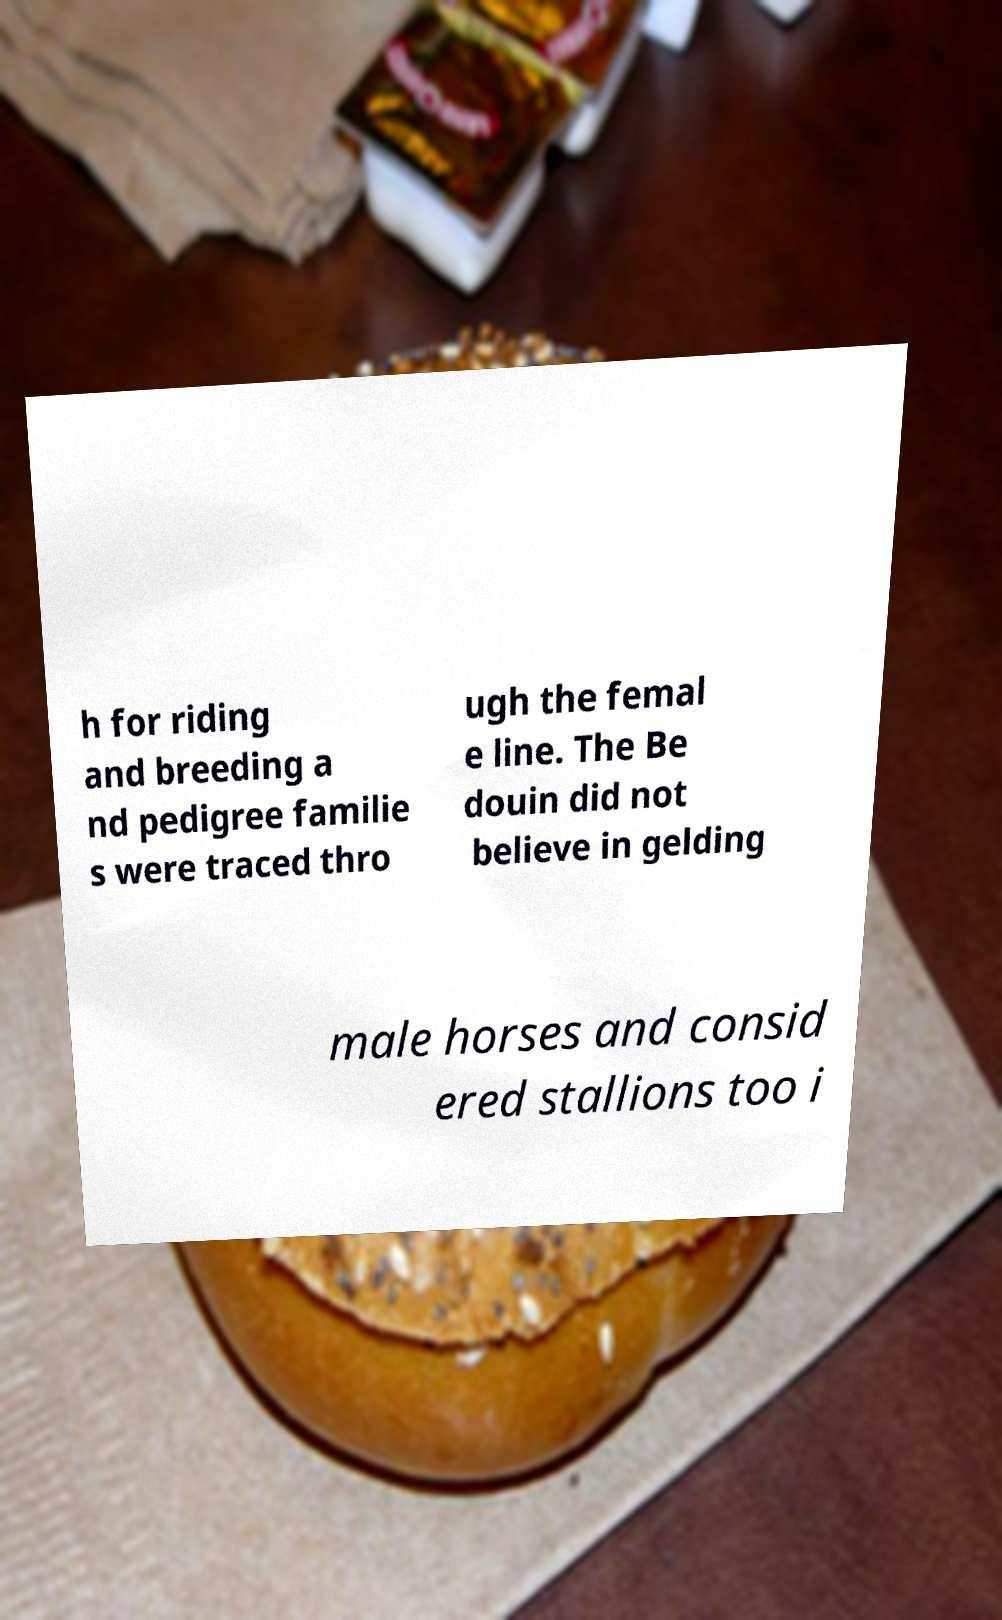Could you assist in decoding the text presented in this image and type it out clearly? h for riding and breeding a nd pedigree familie s were traced thro ugh the femal e line. The Be douin did not believe in gelding male horses and consid ered stallions too i 